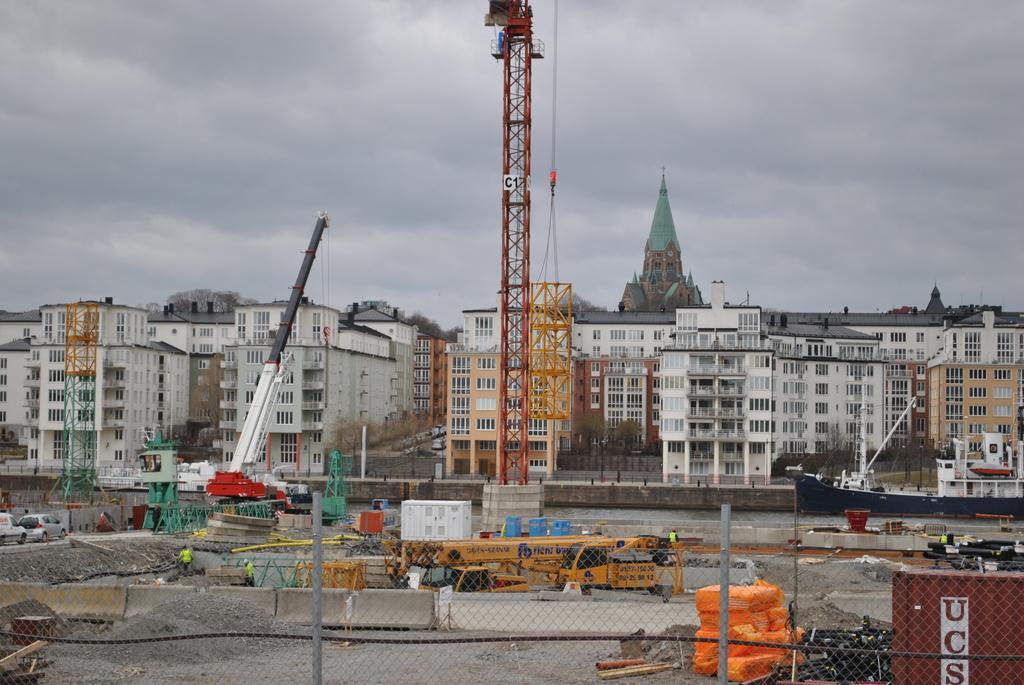Can you describe this image briefly? There is a fencing, construction site, vehicles and buildings. 